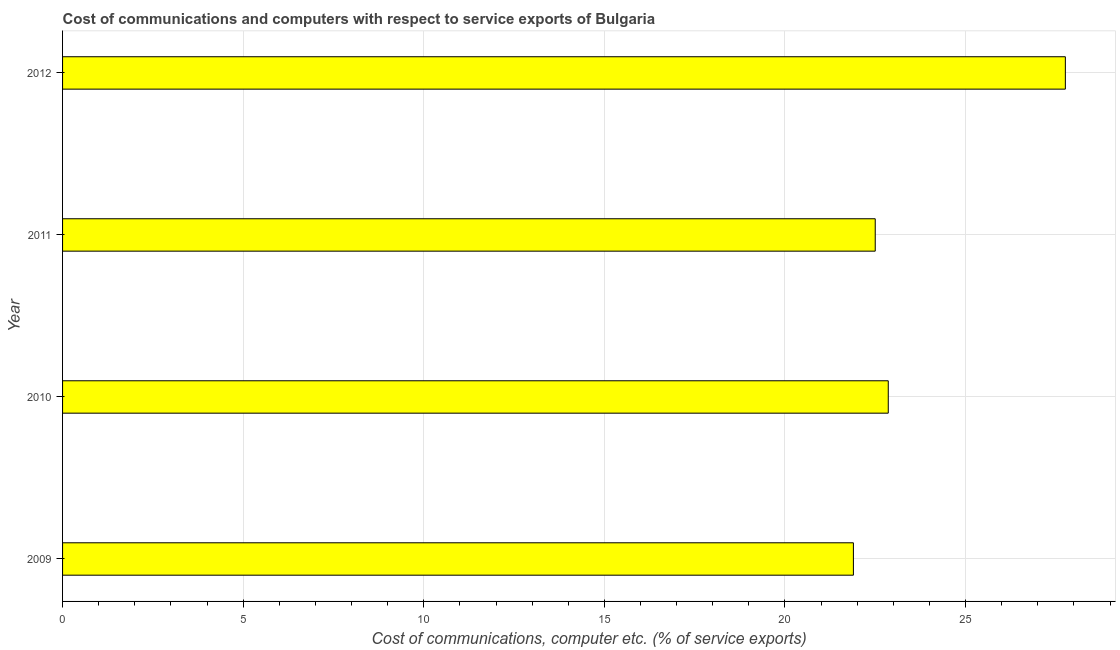What is the title of the graph?
Provide a succinct answer. Cost of communications and computers with respect to service exports of Bulgaria. What is the label or title of the X-axis?
Ensure brevity in your answer.  Cost of communications, computer etc. (% of service exports). What is the cost of communications and computer in 2010?
Provide a short and direct response. 22.86. Across all years, what is the maximum cost of communications and computer?
Ensure brevity in your answer.  27.76. Across all years, what is the minimum cost of communications and computer?
Ensure brevity in your answer.  21.89. In which year was the cost of communications and computer maximum?
Your answer should be very brief. 2012. What is the sum of the cost of communications and computer?
Your response must be concise. 95.02. What is the difference between the cost of communications and computer in 2009 and 2010?
Your answer should be compact. -0.96. What is the average cost of communications and computer per year?
Your response must be concise. 23.75. What is the median cost of communications and computer?
Provide a succinct answer. 22.68. Do a majority of the years between 2011 and 2012 (inclusive) have cost of communications and computer greater than 2 %?
Offer a very short reply. Yes. What is the ratio of the cost of communications and computer in 2011 to that in 2012?
Make the answer very short. 0.81. Is the difference between the cost of communications and computer in 2009 and 2010 greater than the difference between any two years?
Offer a terse response. No. What is the difference between the highest and the second highest cost of communications and computer?
Offer a terse response. 4.9. What is the difference between the highest and the lowest cost of communications and computer?
Offer a very short reply. 5.87. In how many years, is the cost of communications and computer greater than the average cost of communications and computer taken over all years?
Provide a short and direct response. 1. How many years are there in the graph?
Your answer should be very brief. 4. Are the values on the major ticks of X-axis written in scientific E-notation?
Ensure brevity in your answer.  No. What is the Cost of communications, computer etc. (% of service exports) of 2009?
Offer a terse response. 21.89. What is the Cost of communications, computer etc. (% of service exports) of 2010?
Your answer should be compact. 22.86. What is the Cost of communications, computer etc. (% of service exports) in 2011?
Ensure brevity in your answer.  22.5. What is the Cost of communications, computer etc. (% of service exports) in 2012?
Keep it short and to the point. 27.76. What is the difference between the Cost of communications, computer etc. (% of service exports) in 2009 and 2010?
Your response must be concise. -0.97. What is the difference between the Cost of communications, computer etc. (% of service exports) in 2009 and 2011?
Make the answer very short. -0.6. What is the difference between the Cost of communications, computer etc. (% of service exports) in 2009 and 2012?
Your answer should be compact. -5.87. What is the difference between the Cost of communications, computer etc. (% of service exports) in 2010 and 2011?
Provide a short and direct response. 0.36. What is the difference between the Cost of communications, computer etc. (% of service exports) in 2010 and 2012?
Make the answer very short. -4.9. What is the difference between the Cost of communications, computer etc. (% of service exports) in 2011 and 2012?
Provide a succinct answer. -5.26. What is the ratio of the Cost of communications, computer etc. (% of service exports) in 2009 to that in 2010?
Provide a short and direct response. 0.96. What is the ratio of the Cost of communications, computer etc. (% of service exports) in 2009 to that in 2012?
Your response must be concise. 0.79. What is the ratio of the Cost of communications, computer etc. (% of service exports) in 2010 to that in 2011?
Your answer should be compact. 1.02. What is the ratio of the Cost of communications, computer etc. (% of service exports) in 2010 to that in 2012?
Make the answer very short. 0.82. What is the ratio of the Cost of communications, computer etc. (% of service exports) in 2011 to that in 2012?
Give a very brief answer. 0.81. 